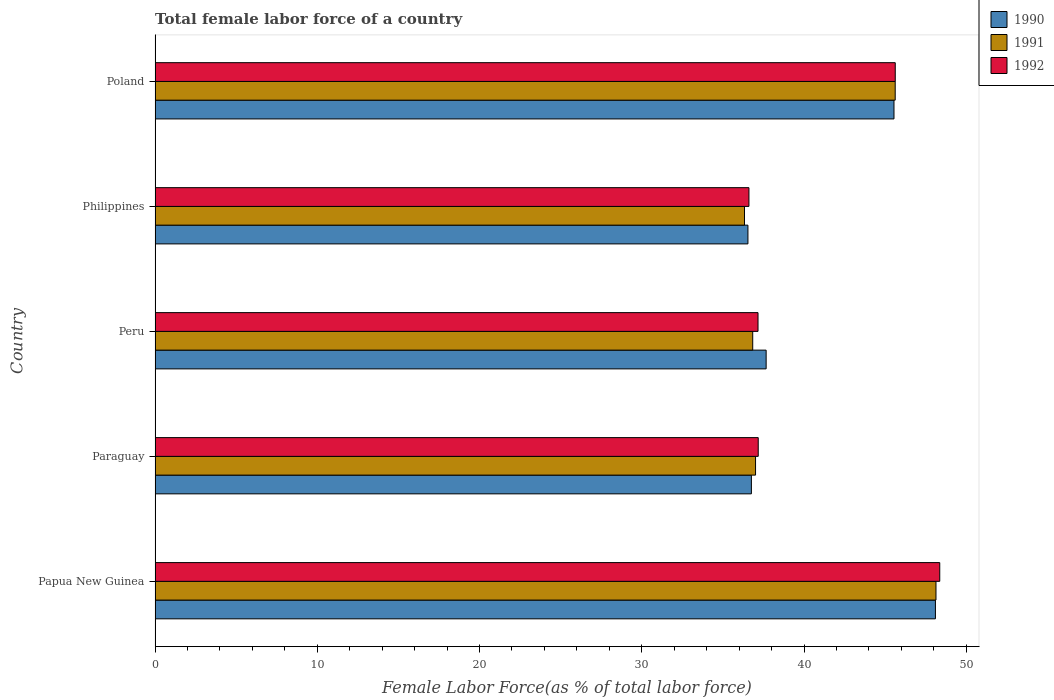How many different coloured bars are there?
Ensure brevity in your answer.  3. How many groups of bars are there?
Ensure brevity in your answer.  5. How many bars are there on the 5th tick from the top?
Give a very brief answer. 3. In how many cases, is the number of bars for a given country not equal to the number of legend labels?
Your response must be concise. 0. What is the percentage of female labor force in 1990 in Peru?
Offer a very short reply. 37.67. Across all countries, what is the maximum percentage of female labor force in 1990?
Make the answer very short. 48.1. Across all countries, what is the minimum percentage of female labor force in 1990?
Offer a terse response. 36.54. In which country was the percentage of female labor force in 1991 maximum?
Provide a succinct answer. Papua New Guinea. In which country was the percentage of female labor force in 1990 minimum?
Your answer should be compact. Philippines. What is the total percentage of female labor force in 1990 in the graph?
Offer a terse response. 204.61. What is the difference between the percentage of female labor force in 1991 in Peru and that in Philippines?
Ensure brevity in your answer.  0.51. What is the difference between the percentage of female labor force in 1992 in Peru and the percentage of female labor force in 1990 in Papua New Guinea?
Offer a terse response. -10.93. What is the average percentage of female labor force in 1992 per country?
Offer a very short reply. 40.99. What is the difference between the percentage of female labor force in 1990 and percentage of female labor force in 1991 in Papua New Guinea?
Your response must be concise. -0.04. In how many countries, is the percentage of female labor force in 1991 greater than 10 %?
Ensure brevity in your answer.  5. What is the ratio of the percentage of female labor force in 1991 in Peru to that in Philippines?
Your response must be concise. 1.01. What is the difference between the highest and the second highest percentage of female labor force in 1992?
Provide a succinct answer. 2.74. What is the difference between the highest and the lowest percentage of female labor force in 1992?
Offer a very short reply. 11.76. In how many countries, is the percentage of female labor force in 1990 greater than the average percentage of female labor force in 1990 taken over all countries?
Your answer should be compact. 2. What does the 1st bar from the bottom in Papua New Guinea represents?
Ensure brevity in your answer.  1990. How many bars are there?
Your answer should be compact. 15. How many countries are there in the graph?
Give a very brief answer. 5. What is the difference between two consecutive major ticks on the X-axis?
Your answer should be compact. 10. Are the values on the major ticks of X-axis written in scientific E-notation?
Your response must be concise. No. Does the graph contain grids?
Provide a succinct answer. No. Where does the legend appear in the graph?
Offer a terse response. Top right. How are the legend labels stacked?
Your answer should be compact. Vertical. What is the title of the graph?
Keep it short and to the point. Total female labor force of a country. Does "1974" appear as one of the legend labels in the graph?
Your answer should be very brief. No. What is the label or title of the X-axis?
Provide a short and direct response. Female Labor Force(as % of total labor force). What is the label or title of the Y-axis?
Your response must be concise. Country. What is the Female Labor Force(as % of total labor force) of 1990 in Papua New Guinea?
Provide a short and direct response. 48.1. What is the Female Labor Force(as % of total labor force) in 1991 in Papua New Guinea?
Give a very brief answer. 48.13. What is the Female Labor Force(as % of total labor force) in 1992 in Papua New Guinea?
Your response must be concise. 48.37. What is the Female Labor Force(as % of total labor force) in 1990 in Paraguay?
Your response must be concise. 36.76. What is the Female Labor Force(as % of total labor force) of 1991 in Paraguay?
Offer a terse response. 37.01. What is the Female Labor Force(as % of total labor force) in 1992 in Paraguay?
Your answer should be very brief. 37.18. What is the Female Labor Force(as % of total labor force) in 1990 in Peru?
Make the answer very short. 37.67. What is the Female Labor Force(as % of total labor force) of 1991 in Peru?
Provide a short and direct response. 36.84. What is the Female Labor Force(as % of total labor force) of 1992 in Peru?
Provide a short and direct response. 37.16. What is the Female Labor Force(as % of total labor force) in 1990 in Philippines?
Give a very brief answer. 36.54. What is the Female Labor Force(as % of total labor force) of 1991 in Philippines?
Keep it short and to the point. 36.33. What is the Female Labor Force(as % of total labor force) in 1992 in Philippines?
Offer a terse response. 36.6. What is the Female Labor Force(as % of total labor force) in 1990 in Poland?
Provide a short and direct response. 45.55. What is the Female Labor Force(as % of total labor force) of 1991 in Poland?
Your response must be concise. 45.62. What is the Female Labor Force(as % of total labor force) in 1992 in Poland?
Offer a very short reply. 45.62. Across all countries, what is the maximum Female Labor Force(as % of total labor force) in 1990?
Make the answer very short. 48.1. Across all countries, what is the maximum Female Labor Force(as % of total labor force) of 1991?
Provide a short and direct response. 48.13. Across all countries, what is the maximum Female Labor Force(as % of total labor force) of 1992?
Provide a succinct answer. 48.37. Across all countries, what is the minimum Female Labor Force(as % of total labor force) in 1990?
Offer a terse response. 36.54. Across all countries, what is the minimum Female Labor Force(as % of total labor force) in 1991?
Your answer should be very brief. 36.33. Across all countries, what is the minimum Female Labor Force(as % of total labor force) in 1992?
Ensure brevity in your answer.  36.6. What is the total Female Labor Force(as % of total labor force) of 1990 in the graph?
Offer a terse response. 204.61. What is the total Female Labor Force(as % of total labor force) of 1991 in the graph?
Keep it short and to the point. 203.94. What is the total Female Labor Force(as % of total labor force) of 1992 in the graph?
Keep it short and to the point. 204.94. What is the difference between the Female Labor Force(as % of total labor force) in 1990 in Papua New Guinea and that in Paraguay?
Offer a very short reply. 11.34. What is the difference between the Female Labor Force(as % of total labor force) in 1991 in Papua New Guinea and that in Paraguay?
Give a very brief answer. 11.12. What is the difference between the Female Labor Force(as % of total labor force) in 1992 in Papua New Guinea and that in Paraguay?
Offer a terse response. 11.19. What is the difference between the Female Labor Force(as % of total labor force) of 1990 in Papua New Guinea and that in Peru?
Your answer should be compact. 10.43. What is the difference between the Female Labor Force(as % of total labor force) of 1991 in Papua New Guinea and that in Peru?
Your response must be concise. 11.3. What is the difference between the Female Labor Force(as % of total labor force) of 1992 in Papua New Guinea and that in Peru?
Offer a very short reply. 11.2. What is the difference between the Female Labor Force(as % of total labor force) of 1990 in Papua New Guinea and that in Philippines?
Ensure brevity in your answer.  11.56. What is the difference between the Female Labor Force(as % of total labor force) in 1991 in Papua New Guinea and that in Philippines?
Give a very brief answer. 11.8. What is the difference between the Female Labor Force(as % of total labor force) of 1992 in Papua New Guinea and that in Philippines?
Provide a short and direct response. 11.76. What is the difference between the Female Labor Force(as % of total labor force) in 1990 in Papua New Guinea and that in Poland?
Provide a succinct answer. 2.55. What is the difference between the Female Labor Force(as % of total labor force) in 1991 in Papua New Guinea and that in Poland?
Give a very brief answer. 2.51. What is the difference between the Female Labor Force(as % of total labor force) of 1992 in Papua New Guinea and that in Poland?
Your answer should be compact. 2.74. What is the difference between the Female Labor Force(as % of total labor force) in 1990 in Paraguay and that in Peru?
Keep it short and to the point. -0.91. What is the difference between the Female Labor Force(as % of total labor force) of 1991 in Paraguay and that in Peru?
Keep it short and to the point. 0.17. What is the difference between the Female Labor Force(as % of total labor force) in 1992 in Paraguay and that in Peru?
Make the answer very short. 0.01. What is the difference between the Female Labor Force(as % of total labor force) of 1990 in Paraguay and that in Philippines?
Your response must be concise. 0.21. What is the difference between the Female Labor Force(as % of total labor force) of 1991 in Paraguay and that in Philippines?
Offer a very short reply. 0.68. What is the difference between the Female Labor Force(as % of total labor force) in 1992 in Paraguay and that in Philippines?
Offer a very short reply. 0.57. What is the difference between the Female Labor Force(as % of total labor force) in 1990 in Paraguay and that in Poland?
Ensure brevity in your answer.  -8.79. What is the difference between the Female Labor Force(as % of total labor force) in 1991 in Paraguay and that in Poland?
Your answer should be very brief. -8.61. What is the difference between the Female Labor Force(as % of total labor force) in 1992 in Paraguay and that in Poland?
Your answer should be very brief. -8.44. What is the difference between the Female Labor Force(as % of total labor force) of 1990 in Peru and that in Philippines?
Provide a short and direct response. 1.12. What is the difference between the Female Labor Force(as % of total labor force) in 1991 in Peru and that in Philippines?
Offer a terse response. 0.51. What is the difference between the Female Labor Force(as % of total labor force) of 1992 in Peru and that in Philippines?
Ensure brevity in your answer.  0.56. What is the difference between the Female Labor Force(as % of total labor force) of 1990 in Peru and that in Poland?
Ensure brevity in your answer.  -7.88. What is the difference between the Female Labor Force(as % of total labor force) of 1991 in Peru and that in Poland?
Your response must be concise. -8.78. What is the difference between the Female Labor Force(as % of total labor force) of 1992 in Peru and that in Poland?
Your answer should be compact. -8.46. What is the difference between the Female Labor Force(as % of total labor force) of 1990 in Philippines and that in Poland?
Offer a terse response. -9. What is the difference between the Female Labor Force(as % of total labor force) in 1991 in Philippines and that in Poland?
Make the answer very short. -9.29. What is the difference between the Female Labor Force(as % of total labor force) in 1992 in Philippines and that in Poland?
Make the answer very short. -9.02. What is the difference between the Female Labor Force(as % of total labor force) in 1990 in Papua New Guinea and the Female Labor Force(as % of total labor force) in 1991 in Paraguay?
Your response must be concise. 11.09. What is the difference between the Female Labor Force(as % of total labor force) in 1990 in Papua New Guinea and the Female Labor Force(as % of total labor force) in 1992 in Paraguay?
Make the answer very short. 10.92. What is the difference between the Female Labor Force(as % of total labor force) in 1991 in Papua New Guinea and the Female Labor Force(as % of total labor force) in 1992 in Paraguay?
Your response must be concise. 10.96. What is the difference between the Female Labor Force(as % of total labor force) of 1990 in Papua New Guinea and the Female Labor Force(as % of total labor force) of 1991 in Peru?
Your answer should be very brief. 11.26. What is the difference between the Female Labor Force(as % of total labor force) of 1990 in Papua New Guinea and the Female Labor Force(as % of total labor force) of 1992 in Peru?
Offer a terse response. 10.93. What is the difference between the Female Labor Force(as % of total labor force) in 1991 in Papua New Guinea and the Female Labor Force(as % of total labor force) in 1992 in Peru?
Give a very brief answer. 10.97. What is the difference between the Female Labor Force(as % of total labor force) of 1990 in Papua New Guinea and the Female Labor Force(as % of total labor force) of 1991 in Philippines?
Offer a very short reply. 11.77. What is the difference between the Female Labor Force(as % of total labor force) of 1990 in Papua New Guinea and the Female Labor Force(as % of total labor force) of 1992 in Philippines?
Make the answer very short. 11.49. What is the difference between the Female Labor Force(as % of total labor force) in 1991 in Papua New Guinea and the Female Labor Force(as % of total labor force) in 1992 in Philippines?
Offer a terse response. 11.53. What is the difference between the Female Labor Force(as % of total labor force) in 1990 in Papua New Guinea and the Female Labor Force(as % of total labor force) in 1991 in Poland?
Make the answer very short. 2.48. What is the difference between the Female Labor Force(as % of total labor force) in 1990 in Papua New Guinea and the Female Labor Force(as % of total labor force) in 1992 in Poland?
Provide a succinct answer. 2.48. What is the difference between the Female Labor Force(as % of total labor force) in 1991 in Papua New Guinea and the Female Labor Force(as % of total labor force) in 1992 in Poland?
Your answer should be very brief. 2.51. What is the difference between the Female Labor Force(as % of total labor force) in 1990 in Paraguay and the Female Labor Force(as % of total labor force) in 1991 in Peru?
Keep it short and to the point. -0.08. What is the difference between the Female Labor Force(as % of total labor force) of 1990 in Paraguay and the Female Labor Force(as % of total labor force) of 1992 in Peru?
Provide a short and direct response. -0.41. What is the difference between the Female Labor Force(as % of total labor force) of 1991 in Paraguay and the Female Labor Force(as % of total labor force) of 1992 in Peru?
Your response must be concise. -0.15. What is the difference between the Female Labor Force(as % of total labor force) of 1990 in Paraguay and the Female Labor Force(as % of total labor force) of 1991 in Philippines?
Give a very brief answer. 0.42. What is the difference between the Female Labor Force(as % of total labor force) in 1990 in Paraguay and the Female Labor Force(as % of total labor force) in 1992 in Philippines?
Provide a succinct answer. 0.15. What is the difference between the Female Labor Force(as % of total labor force) in 1991 in Paraguay and the Female Labor Force(as % of total labor force) in 1992 in Philippines?
Offer a terse response. 0.41. What is the difference between the Female Labor Force(as % of total labor force) of 1990 in Paraguay and the Female Labor Force(as % of total labor force) of 1991 in Poland?
Provide a succinct answer. -8.86. What is the difference between the Female Labor Force(as % of total labor force) of 1990 in Paraguay and the Female Labor Force(as % of total labor force) of 1992 in Poland?
Your answer should be very brief. -8.87. What is the difference between the Female Labor Force(as % of total labor force) of 1991 in Paraguay and the Female Labor Force(as % of total labor force) of 1992 in Poland?
Provide a short and direct response. -8.61. What is the difference between the Female Labor Force(as % of total labor force) in 1990 in Peru and the Female Labor Force(as % of total labor force) in 1991 in Philippines?
Make the answer very short. 1.33. What is the difference between the Female Labor Force(as % of total labor force) in 1990 in Peru and the Female Labor Force(as % of total labor force) in 1992 in Philippines?
Give a very brief answer. 1.06. What is the difference between the Female Labor Force(as % of total labor force) of 1991 in Peru and the Female Labor Force(as % of total labor force) of 1992 in Philippines?
Your response must be concise. 0.23. What is the difference between the Female Labor Force(as % of total labor force) of 1990 in Peru and the Female Labor Force(as % of total labor force) of 1991 in Poland?
Offer a very short reply. -7.95. What is the difference between the Female Labor Force(as % of total labor force) in 1990 in Peru and the Female Labor Force(as % of total labor force) in 1992 in Poland?
Provide a short and direct response. -7.96. What is the difference between the Female Labor Force(as % of total labor force) in 1991 in Peru and the Female Labor Force(as % of total labor force) in 1992 in Poland?
Offer a very short reply. -8.79. What is the difference between the Female Labor Force(as % of total labor force) in 1990 in Philippines and the Female Labor Force(as % of total labor force) in 1991 in Poland?
Your answer should be compact. -9.08. What is the difference between the Female Labor Force(as % of total labor force) in 1990 in Philippines and the Female Labor Force(as % of total labor force) in 1992 in Poland?
Your answer should be compact. -9.08. What is the difference between the Female Labor Force(as % of total labor force) in 1991 in Philippines and the Female Labor Force(as % of total labor force) in 1992 in Poland?
Give a very brief answer. -9.29. What is the average Female Labor Force(as % of total labor force) in 1990 per country?
Give a very brief answer. 40.92. What is the average Female Labor Force(as % of total labor force) of 1991 per country?
Offer a terse response. 40.79. What is the average Female Labor Force(as % of total labor force) in 1992 per country?
Your response must be concise. 40.99. What is the difference between the Female Labor Force(as % of total labor force) in 1990 and Female Labor Force(as % of total labor force) in 1991 in Papua New Guinea?
Give a very brief answer. -0.04. What is the difference between the Female Labor Force(as % of total labor force) in 1990 and Female Labor Force(as % of total labor force) in 1992 in Papua New Guinea?
Offer a terse response. -0.27. What is the difference between the Female Labor Force(as % of total labor force) in 1991 and Female Labor Force(as % of total labor force) in 1992 in Papua New Guinea?
Your answer should be very brief. -0.23. What is the difference between the Female Labor Force(as % of total labor force) in 1990 and Female Labor Force(as % of total labor force) in 1991 in Paraguay?
Your response must be concise. -0.26. What is the difference between the Female Labor Force(as % of total labor force) in 1990 and Female Labor Force(as % of total labor force) in 1992 in Paraguay?
Provide a short and direct response. -0.42. What is the difference between the Female Labor Force(as % of total labor force) of 1991 and Female Labor Force(as % of total labor force) of 1992 in Paraguay?
Your answer should be very brief. -0.17. What is the difference between the Female Labor Force(as % of total labor force) in 1990 and Female Labor Force(as % of total labor force) in 1991 in Peru?
Keep it short and to the point. 0.83. What is the difference between the Female Labor Force(as % of total labor force) in 1990 and Female Labor Force(as % of total labor force) in 1992 in Peru?
Ensure brevity in your answer.  0.5. What is the difference between the Female Labor Force(as % of total labor force) of 1991 and Female Labor Force(as % of total labor force) of 1992 in Peru?
Your answer should be compact. -0.33. What is the difference between the Female Labor Force(as % of total labor force) of 1990 and Female Labor Force(as % of total labor force) of 1991 in Philippines?
Make the answer very short. 0.21. What is the difference between the Female Labor Force(as % of total labor force) of 1990 and Female Labor Force(as % of total labor force) of 1992 in Philippines?
Make the answer very short. -0.06. What is the difference between the Female Labor Force(as % of total labor force) in 1991 and Female Labor Force(as % of total labor force) in 1992 in Philippines?
Your response must be concise. -0.27. What is the difference between the Female Labor Force(as % of total labor force) in 1990 and Female Labor Force(as % of total labor force) in 1991 in Poland?
Give a very brief answer. -0.07. What is the difference between the Female Labor Force(as % of total labor force) in 1990 and Female Labor Force(as % of total labor force) in 1992 in Poland?
Your answer should be compact. -0.08. What is the difference between the Female Labor Force(as % of total labor force) in 1991 and Female Labor Force(as % of total labor force) in 1992 in Poland?
Your answer should be compact. -0. What is the ratio of the Female Labor Force(as % of total labor force) in 1990 in Papua New Guinea to that in Paraguay?
Ensure brevity in your answer.  1.31. What is the ratio of the Female Labor Force(as % of total labor force) in 1991 in Papua New Guinea to that in Paraguay?
Make the answer very short. 1.3. What is the ratio of the Female Labor Force(as % of total labor force) in 1992 in Papua New Guinea to that in Paraguay?
Offer a terse response. 1.3. What is the ratio of the Female Labor Force(as % of total labor force) in 1990 in Papua New Guinea to that in Peru?
Give a very brief answer. 1.28. What is the ratio of the Female Labor Force(as % of total labor force) in 1991 in Papua New Guinea to that in Peru?
Give a very brief answer. 1.31. What is the ratio of the Female Labor Force(as % of total labor force) of 1992 in Papua New Guinea to that in Peru?
Make the answer very short. 1.3. What is the ratio of the Female Labor Force(as % of total labor force) of 1990 in Papua New Guinea to that in Philippines?
Offer a very short reply. 1.32. What is the ratio of the Female Labor Force(as % of total labor force) of 1991 in Papua New Guinea to that in Philippines?
Offer a terse response. 1.32. What is the ratio of the Female Labor Force(as % of total labor force) of 1992 in Papua New Guinea to that in Philippines?
Your answer should be compact. 1.32. What is the ratio of the Female Labor Force(as % of total labor force) of 1990 in Papua New Guinea to that in Poland?
Keep it short and to the point. 1.06. What is the ratio of the Female Labor Force(as % of total labor force) in 1991 in Papua New Guinea to that in Poland?
Make the answer very short. 1.06. What is the ratio of the Female Labor Force(as % of total labor force) of 1992 in Papua New Guinea to that in Poland?
Your answer should be compact. 1.06. What is the ratio of the Female Labor Force(as % of total labor force) of 1990 in Paraguay to that in Peru?
Provide a succinct answer. 0.98. What is the ratio of the Female Labor Force(as % of total labor force) of 1991 in Paraguay to that in Peru?
Your answer should be very brief. 1. What is the ratio of the Female Labor Force(as % of total labor force) of 1992 in Paraguay to that in Peru?
Make the answer very short. 1. What is the ratio of the Female Labor Force(as % of total labor force) in 1990 in Paraguay to that in Philippines?
Give a very brief answer. 1.01. What is the ratio of the Female Labor Force(as % of total labor force) in 1991 in Paraguay to that in Philippines?
Give a very brief answer. 1.02. What is the ratio of the Female Labor Force(as % of total labor force) in 1992 in Paraguay to that in Philippines?
Make the answer very short. 1.02. What is the ratio of the Female Labor Force(as % of total labor force) of 1990 in Paraguay to that in Poland?
Your answer should be compact. 0.81. What is the ratio of the Female Labor Force(as % of total labor force) in 1991 in Paraguay to that in Poland?
Offer a very short reply. 0.81. What is the ratio of the Female Labor Force(as % of total labor force) of 1992 in Paraguay to that in Poland?
Your answer should be very brief. 0.81. What is the ratio of the Female Labor Force(as % of total labor force) in 1990 in Peru to that in Philippines?
Give a very brief answer. 1.03. What is the ratio of the Female Labor Force(as % of total labor force) in 1991 in Peru to that in Philippines?
Keep it short and to the point. 1.01. What is the ratio of the Female Labor Force(as % of total labor force) in 1992 in Peru to that in Philippines?
Provide a succinct answer. 1.02. What is the ratio of the Female Labor Force(as % of total labor force) in 1990 in Peru to that in Poland?
Provide a succinct answer. 0.83. What is the ratio of the Female Labor Force(as % of total labor force) in 1991 in Peru to that in Poland?
Your response must be concise. 0.81. What is the ratio of the Female Labor Force(as % of total labor force) in 1992 in Peru to that in Poland?
Make the answer very short. 0.81. What is the ratio of the Female Labor Force(as % of total labor force) of 1990 in Philippines to that in Poland?
Your answer should be compact. 0.8. What is the ratio of the Female Labor Force(as % of total labor force) in 1991 in Philippines to that in Poland?
Make the answer very short. 0.8. What is the ratio of the Female Labor Force(as % of total labor force) of 1992 in Philippines to that in Poland?
Make the answer very short. 0.8. What is the difference between the highest and the second highest Female Labor Force(as % of total labor force) of 1990?
Provide a short and direct response. 2.55. What is the difference between the highest and the second highest Female Labor Force(as % of total labor force) of 1991?
Make the answer very short. 2.51. What is the difference between the highest and the second highest Female Labor Force(as % of total labor force) in 1992?
Your answer should be compact. 2.74. What is the difference between the highest and the lowest Female Labor Force(as % of total labor force) in 1990?
Your answer should be very brief. 11.56. What is the difference between the highest and the lowest Female Labor Force(as % of total labor force) of 1991?
Provide a succinct answer. 11.8. What is the difference between the highest and the lowest Female Labor Force(as % of total labor force) in 1992?
Your answer should be very brief. 11.76. 